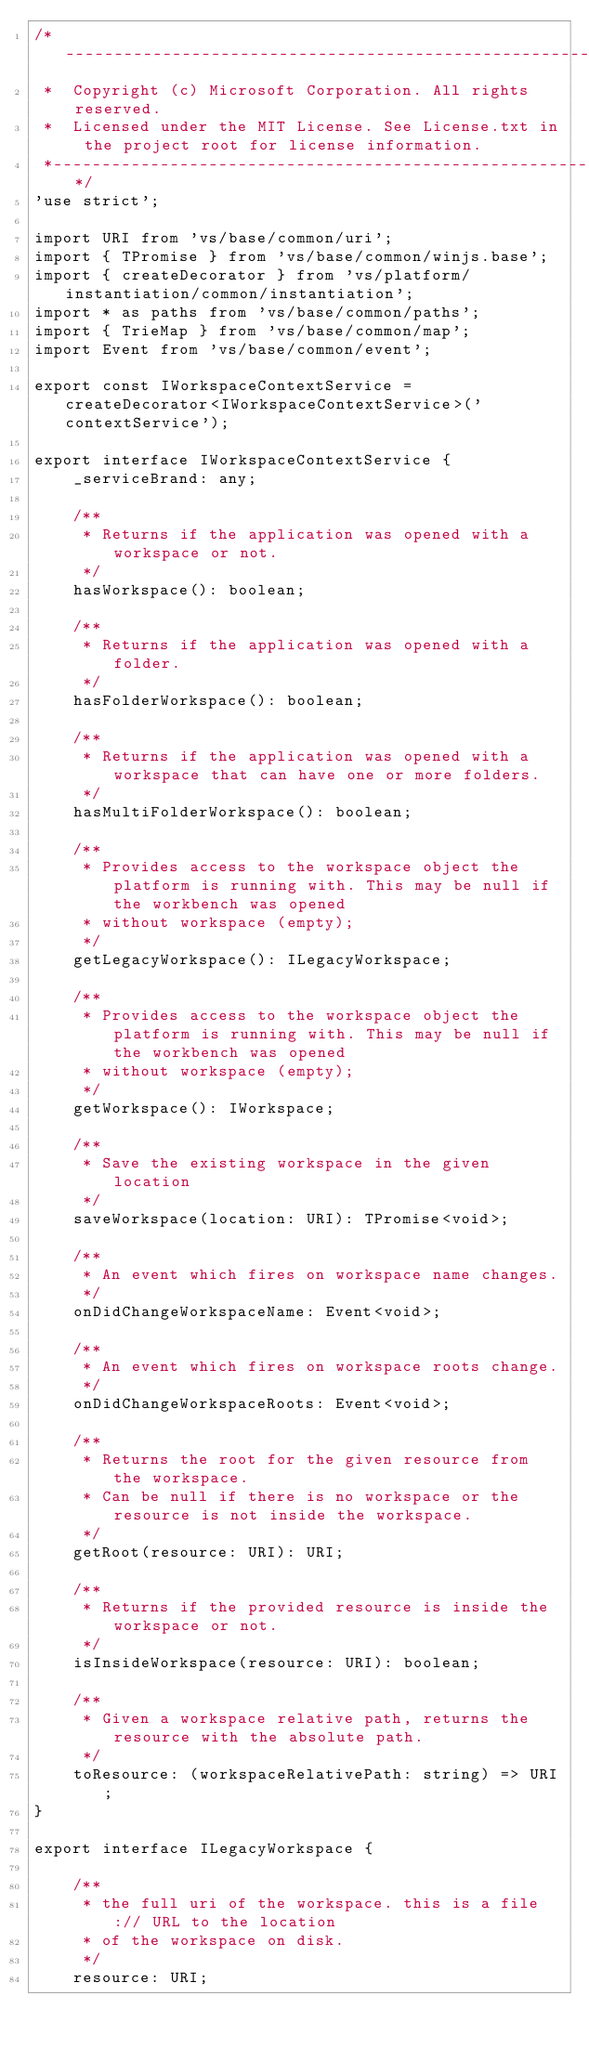Convert code to text. <code><loc_0><loc_0><loc_500><loc_500><_TypeScript_>/*---------------------------------------------------------------------------------------------
 *  Copyright (c) Microsoft Corporation. All rights reserved.
 *  Licensed under the MIT License. See License.txt in the project root for license information.
 *--------------------------------------------------------------------------------------------*/
'use strict';

import URI from 'vs/base/common/uri';
import { TPromise } from 'vs/base/common/winjs.base';
import { createDecorator } from 'vs/platform/instantiation/common/instantiation';
import * as paths from 'vs/base/common/paths';
import { TrieMap } from 'vs/base/common/map';
import Event from 'vs/base/common/event';

export const IWorkspaceContextService = createDecorator<IWorkspaceContextService>('contextService');

export interface IWorkspaceContextService {
	_serviceBrand: any;

	/**
	 * Returns if the application was opened with a workspace or not.
	 */
	hasWorkspace(): boolean;

	/**
	 * Returns if the application was opened with a folder.
	 */
	hasFolderWorkspace(): boolean;

	/**
	 * Returns if the application was opened with a workspace that can have one or more folders.
	 */
	hasMultiFolderWorkspace(): boolean;

	/**
	 * Provides access to the workspace object the platform is running with. This may be null if the workbench was opened
	 * without workspace (empty);
	 */
	getLegacyWorkspace(): ILegacyWorkspace;

	/**
	 * Provides access to the workspace object the platform is running with. This may be null if the workbench was opened
	 * without workspace (empty);
	 */
	getWorkspace(): IWorkspace;

	/**
	 * Save the existing workspace in the given location
	 */
	saveWorkspace(location: URI): TPromise<void>;

	/**
	 * An event which fires on workspace name changes.
	 */
	onDidChangeWorkspaceName: Event<void>;

	/**
	 * An event which fires on workspace roots change.
	 */
	onDidChangeWorkspaceRoots: Event<void>;

	/**
	 * Returns the root for the given resource from the workspace.
	 * Can be null if there is no workspace or the resource is not inside the workspace.
	 */
	getRoot(resource: URI): URI;

	/**
	 * Returns if the provided resource is inside the workspace or not.
	 */
	isInsideWorkspace(resource: URI): boolean;

	/**
	 * Given a workspace relative path, returns the resource with the absolute path.
	 */
	toResource: (workspaceRelativePath: string) => URI;
}

export interface ILegacyWorkspace {

	/**
	 * the full uri of the workspace. this is a file:// URL to the location
	 * of the workspace on disk.
	 */
	resource: URI;
</code> 